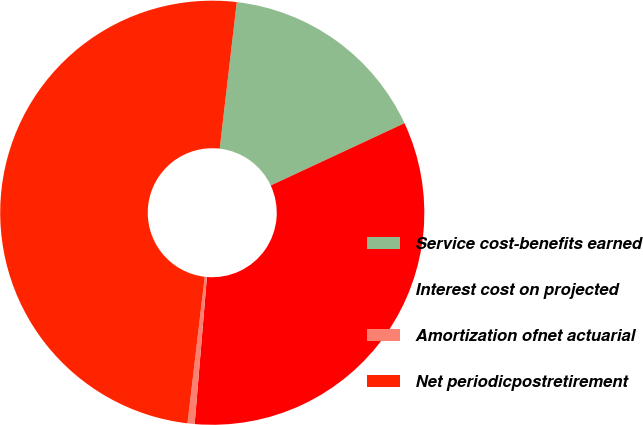Convert chart to OTSL. <chart><loc_0><loc_0><loc_500><loc_500><pie_chart><fcel>Service cost-benefits earned<fcel>Interest cost on projected<fcel>Amortization ofnet actuarial<fcel>Net periodicpostretirement<nl><fcel>16.22%<fcel>33.26%<fcel>0.54%<fcel>49.98%<nl></chart> 